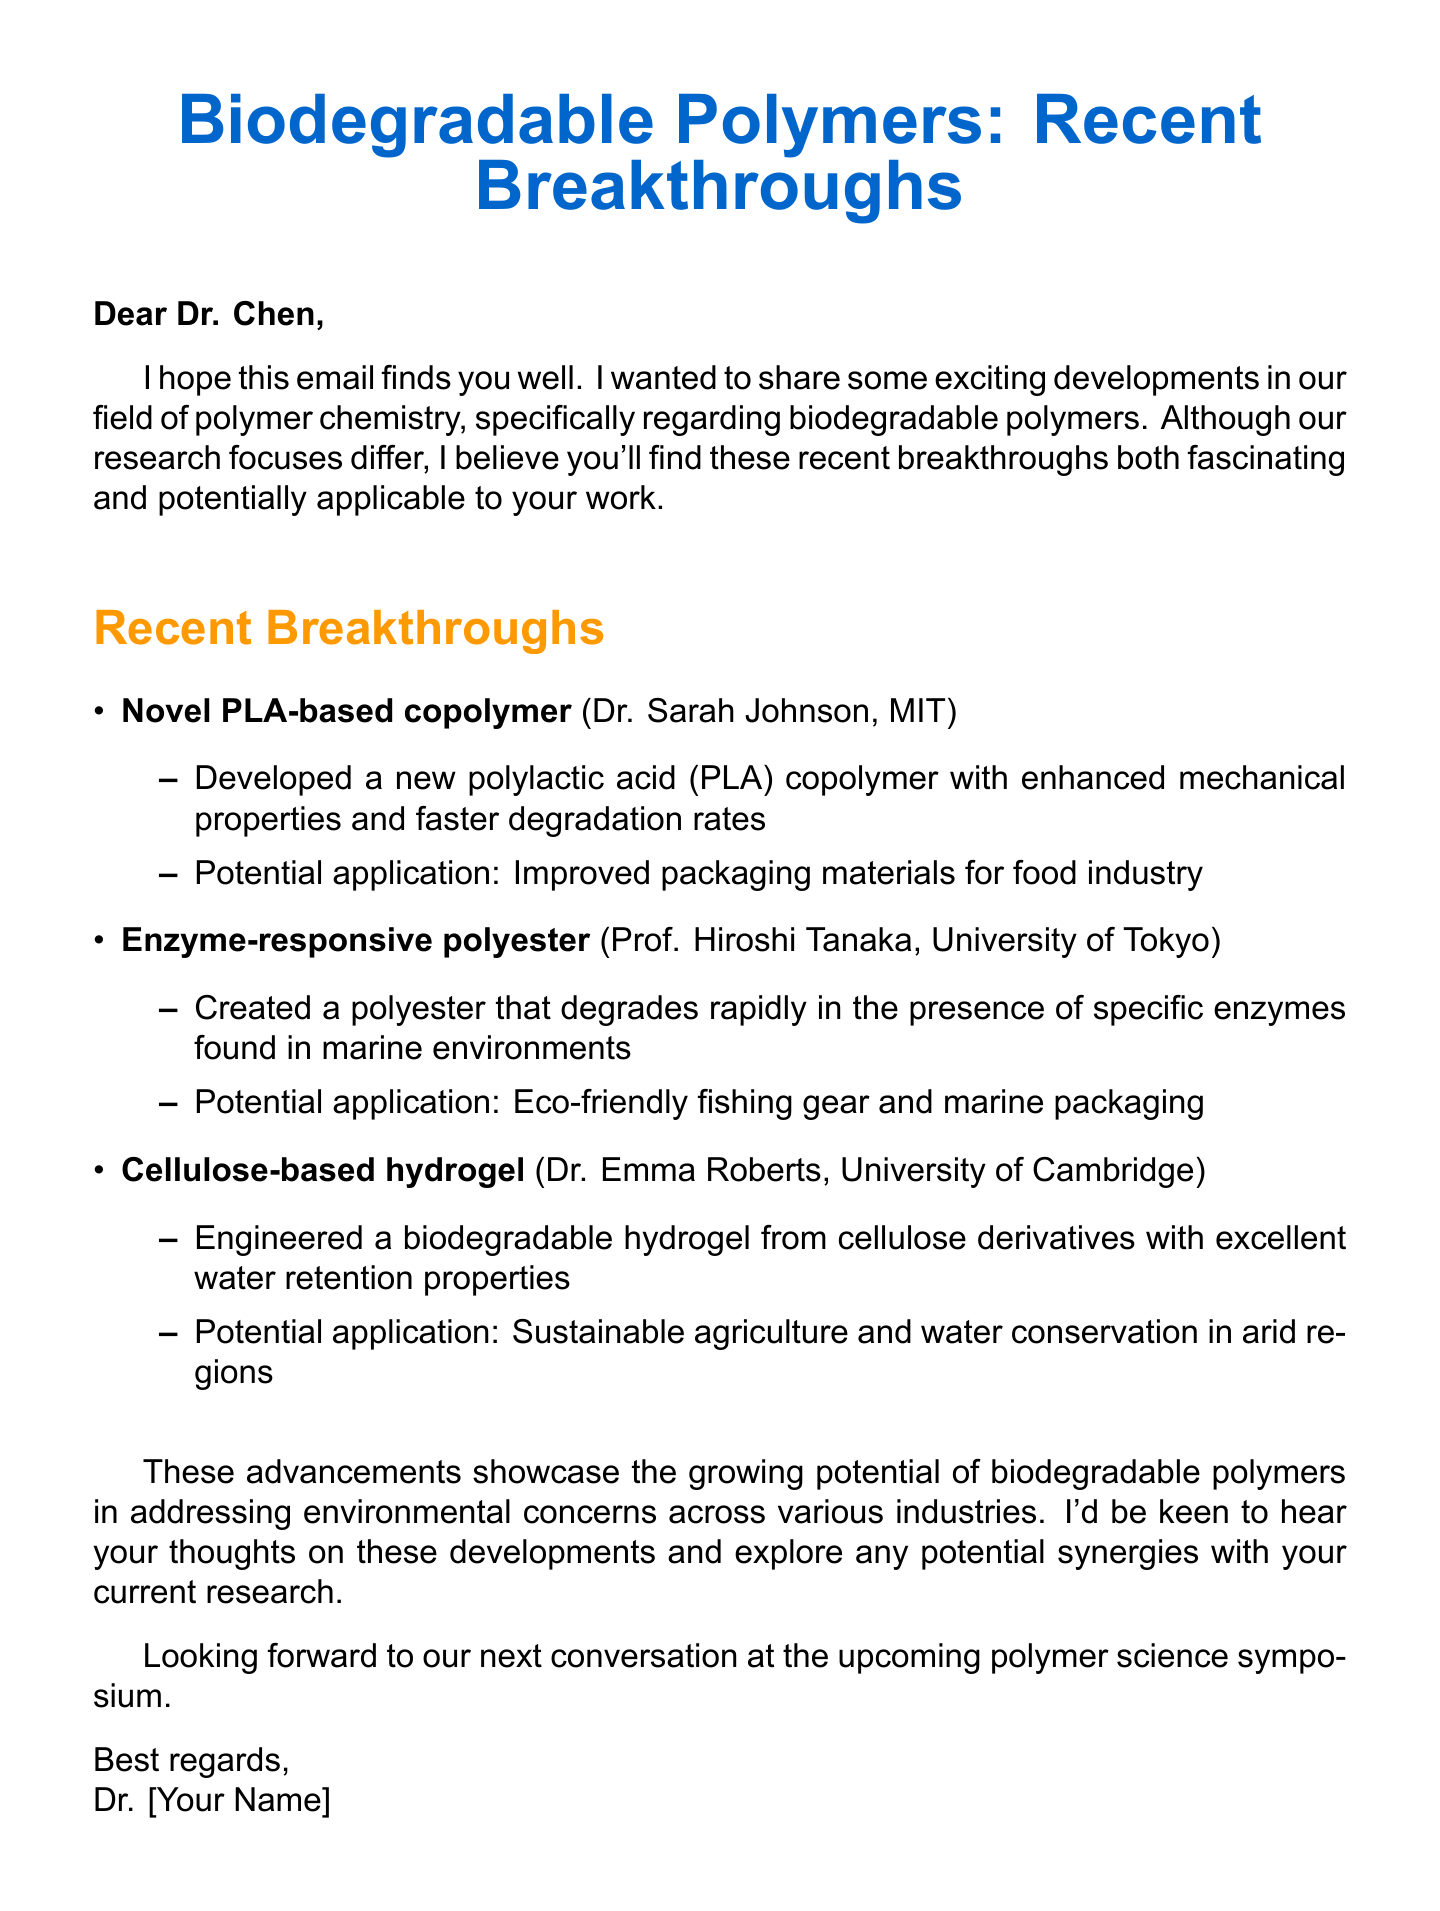What is the name of the PLA-based copolymer developed? The document states that the breakthrough is a "Novel PLA-based copolymer" developed by Dr. Sarah Johnson and her team.
Answer: Novel PLA-based copolymer Who is the researcher behind the enzyme-responsive polyester? The document mentions Prof. Hiroshi Tanaka's group at the University of Tokyo as the researchers for the enzyme-responsive polyester.
Answer: Prof. Hiroshi Tanaka What application is suggested for the cellulose-based hydrogel? The document lists "Sustainable agriculture and water conservation in arid regions" as the potential application for the cellulose-based hydrogel.
Answer: Sustainable agriculture and water conservation in arid regions How many breakthroughs in biodegradable polymers are discussed in the email? The document outlines three breakthroughs in biodegradable polymers.
Answer: Three What are the enhanced features of the Novel PLA-based copolymer? The document indicates that the copolymer has "enhanced mechanical properties and faster degradation rates."
Answer: Enhanced mechanical properties and faster degradation rates Which environmental concern does the email highlight in relation to biodegradable polymers? The document summarizes that these advancements could address "environmental concerns across various industries."
Answer: Environmental concerns What kind of polymer was developed by Dr. Emma Roberts? The document describes that Dr. Emma Roberts engineered a "biodegradable hydrogel from cellulose derivatives."
Answer: Biodegradable hydrogel What is the main purpose of the email? The purpose of the email is to share recent developments in biodegradable polymers and explore potential synergies in research.
Answer: Share recent developments and explore potential synergies What does the sender hope to hear from Dr. Chen? The sender expresses a desire to hear Dr. Chen’s thoughts on the developments and to discuss potential synergies.
Answer: Dr. Chen’s thoughts on the developments and discuss potential synergies 